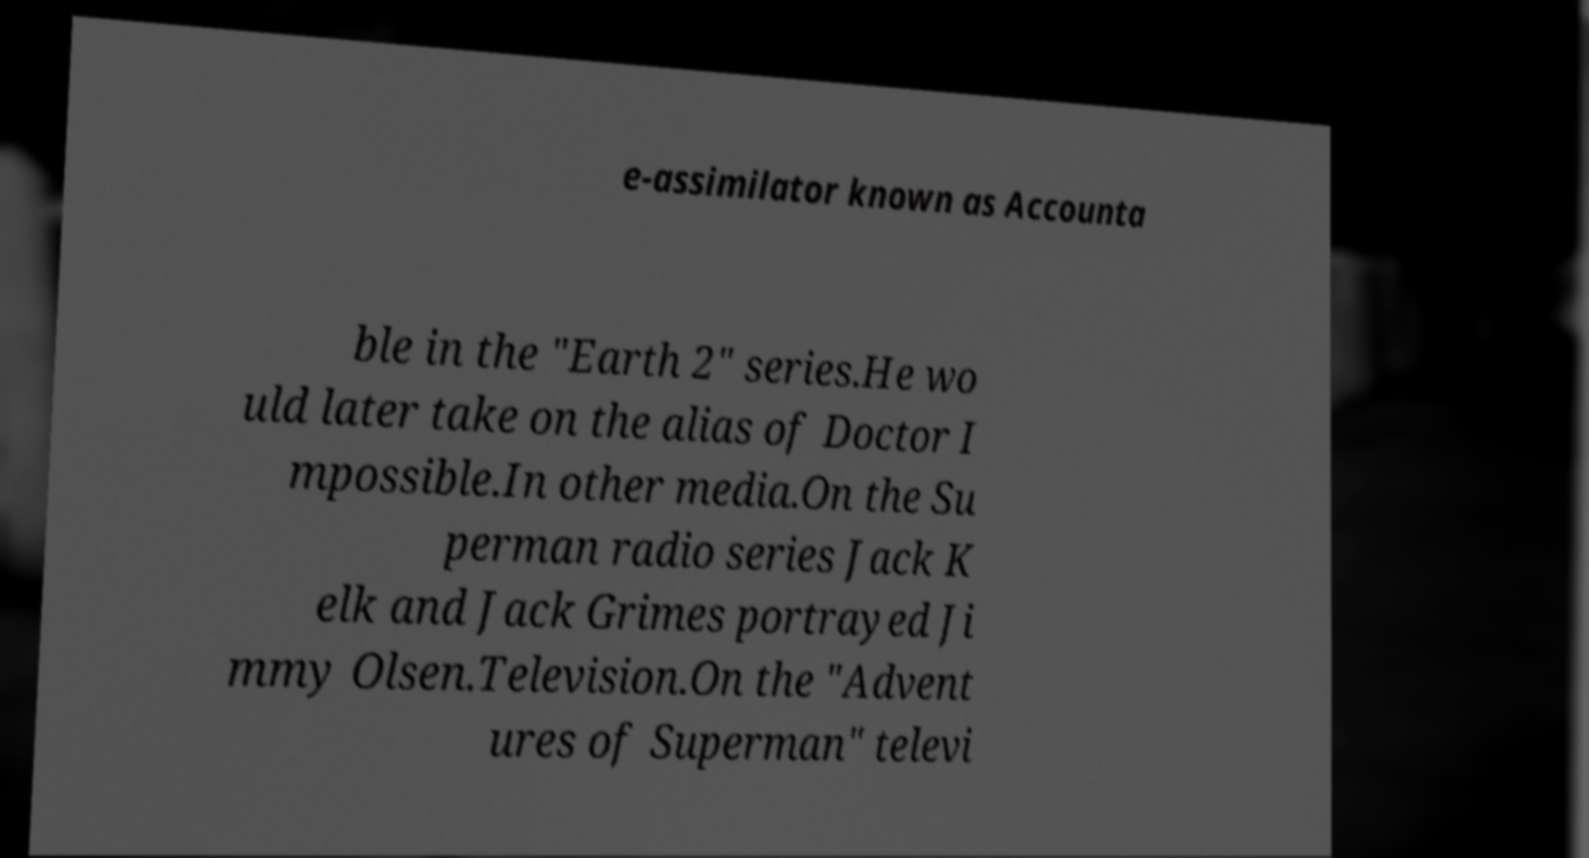Please read and relay the text visible in this image. What does it say? e-assimilator known as Accounta ble in the "Earth 2" series.He wo uld later take on the alias of Doctor I mpossible.In other media.On the Su perman radio series Jack K elk and Jack Grimes portrayed Ji mmy Olsen.Television.On the "Advent ures of Superman" televi 